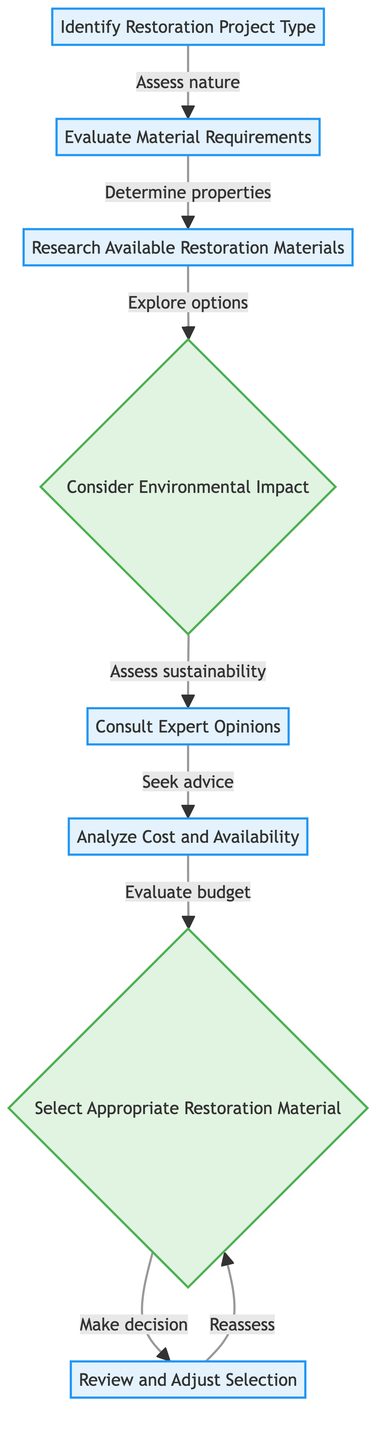What is the first step in the flowchart? The first node in the flowchart is "Identify Restoration Project Type," which indicates that the process begins with assessing the type of restoration project needed.
Answer: Identify Restoration Project Type How many total nodes are present in the diagram? The diagram has a total of 8 nodes, including decision and process nodes, indicating the various steps involved in the decision-making process for selecting restoration materials.
Answer: 8 Which step follows "Research Available Restoration Materials"? After "Research Available Restoration Materials," the next node is "Consider Environmental Impact," showing that evaluating the sustainability of materials comes after researching available options.
Answer: Consider Environmental Impact What decision must be made after analyzing costs and availability? After "Analyze Cost and Availability," the decision made is in the node "Select Appropriate Restoration Material," where the selection of materials is determined based on gathered information.
Answer: Select Appropriate Restoration Material Which node represents the assessment of sustainability? The node that represents the assessment of sustainability is "Consider Environmental Impact." This step focuses on evaluating the environmental effects of the selected materials.
Answer: Consider Environmental Impact Explain the flow from "Evaluate Material Requirements" to the final step. The flow starts at "Evaluate Material Requirements," which leads to "Research Available Restoration Materials," then moves to "Consider Environmental Impact." Next, it goes to "Consult Expert Opinions," followed by "Analyze Cost and Availability," finally leading to "Select Appropriate Restoration Material" and then "Review and Adjust Selection." This indicates a systematic approach from evaluating needs to making a decision and finalizing the selection.
Answer: Review and Adjust Selection What type of node follows "Consult Expert Opinions"? The node that follows "Consult Expert Opinions" is "Analyze Cost and Availability," which is a process node where the cost and sourcing options are evaluated after seeking expert advice.
Answer: Analyze Cost and Availability Is "Select Appropriate Restoration Material" a decision or process node? "Select Appropriate Restoration Material" is a decision node, indicating that this step involves making an informed choice based on previously gathered information.
Answer: Decision node 